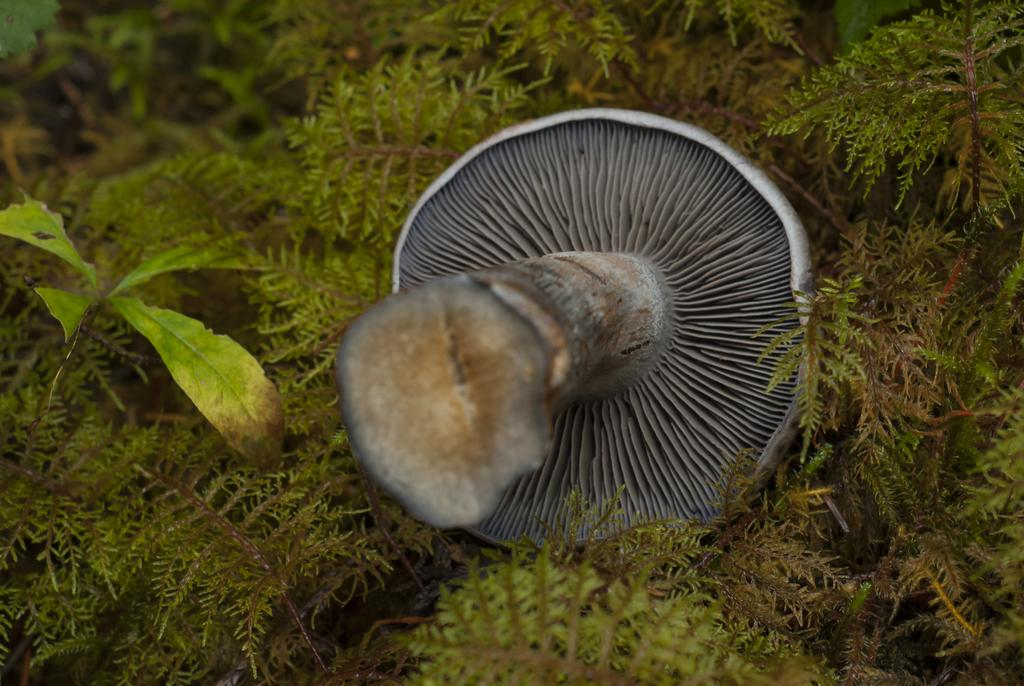Where was the image taken? The image was taken outdoors. What type of natural elements can be seen in the image? There are plants in the image. What is the main subject in the middle of the image? There is a mushroom in the middle of the image. Can you tell me how the mushroom is affecting the mind of the person in the image? There is no person present in the image, and therefore no mind to be affected by the mushroom. 